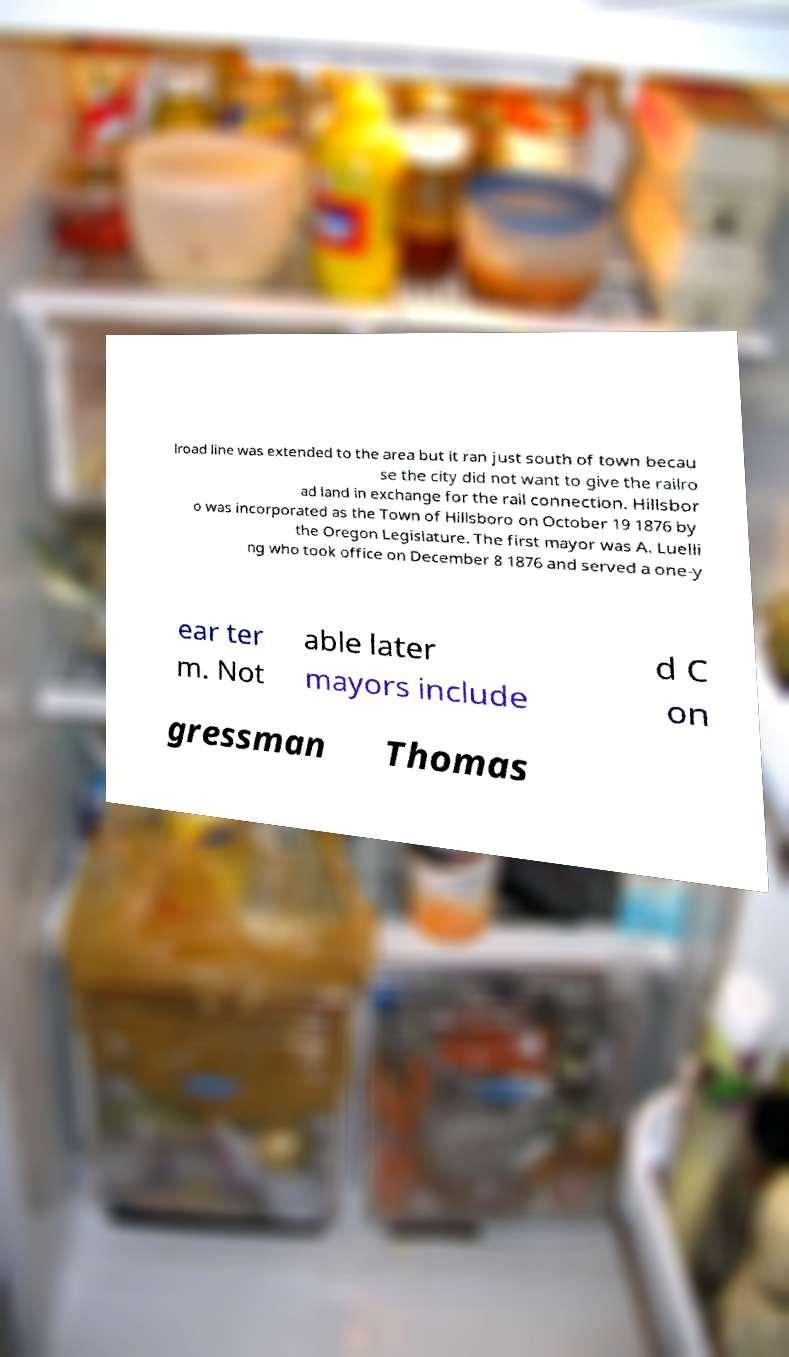Can you read and provide the text displayed in the image?This photo seems to have some interesting text. Can you extract and type it out for me? lroad line was extended to the area but it ran just south of town becau se the city did not want to give the railro ad land in exchange for the rail connection. Hillsbor o was incorporated as the Town of Hillsboro on October 19 1876 by the Oregon Legislature. The first mayor was A. Luelli ng who took office on December 8 1876 and served a one-y ear ter m. Not able later mayors include d C on gressman Thomas 